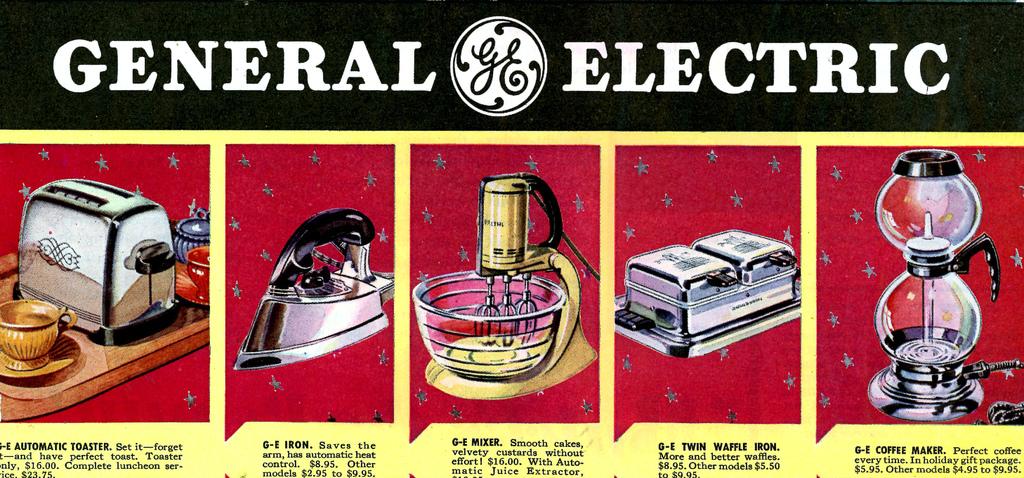What company made these products?
Keep it short and to the point. General electric. What brand are these products from?
Offer a terse response. General electric. 